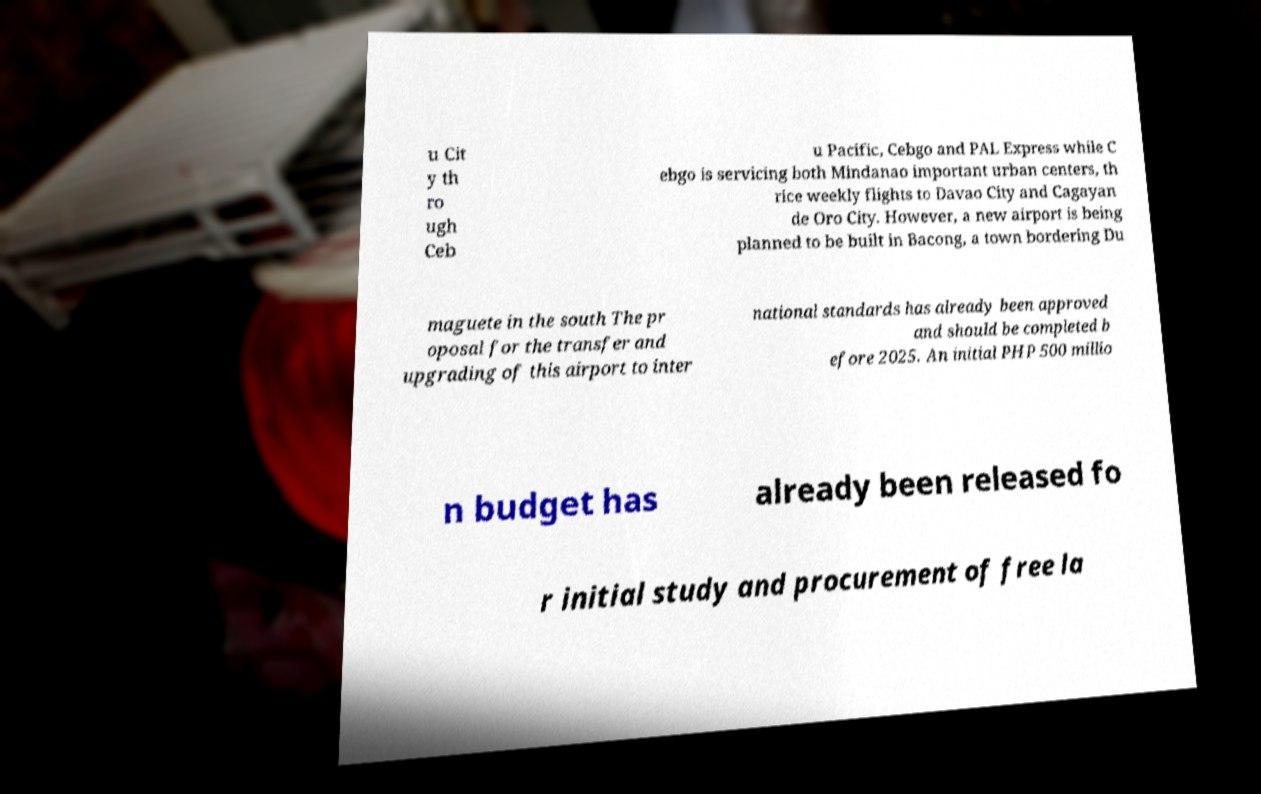Can you accurately transcribe the text from the provided image for me? u Cit y th ro ugh Ceb u Pacific, Cebgo and PAL Express while C ebgo is servicing both Mindanao important urban centers, th rice weekly flights to Davao City and Cagayan de Oro City. However, a new airport is being planned to be built in Bacong, a town bordering Du maguete in the south The pr oposal for the transfer and upgrading of this airport to inter national standards has already been approved and should be completed b efore 2025. An initial PHP 500 millio n budget has already been released fo r initial study and procurement of free la 